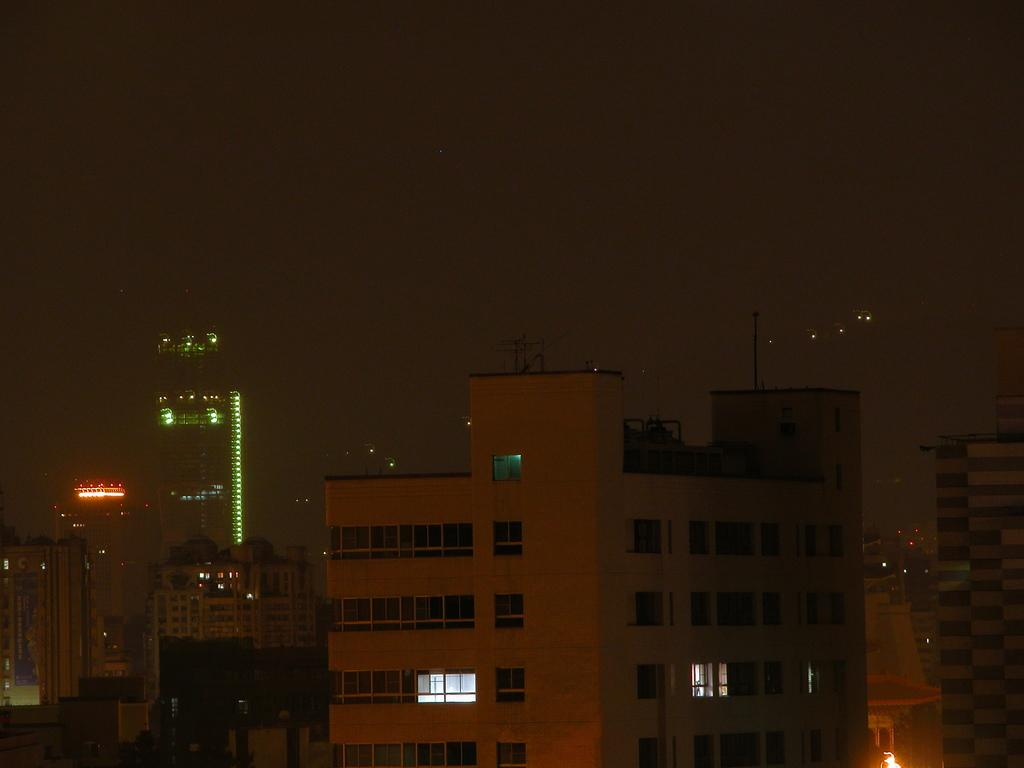What time of day was the image taken? The image was taken at night. What structures can be seen in the image? There are buildings in the image. What is visible at the top of the image? The sky is visible at the top of the image. What type of oil is being used to cook the food in the image? There is no food or oil present in the image; it features buildings at night with a visible sky. 